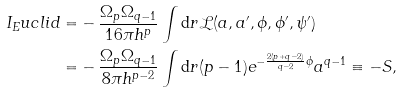Convert formula to latex. <formula><loc_0><loc_0><loc_500><loc_500>I _ { E } u c l i d = & - \frac { \Omega _ { p } \Omega _ { q - 1 } } { 1 6 \pi h ^ { p } } \int \mathrm d r \mathcal { L } ( a , a ^ { \prime } , \phi , \phi ^ { \prime } , \psi ^ { \prime } ) \\ = & - \frac { \Omega _ { p } \Omega _ { q - 1 } } { 8 \pi h ^ { p - 2 } } \int \mathrm d r ( p - 1 ) e ^ { - \frac { 2 ( p + q - 2 ) } { q - 2 } \phi } a ^ { q - 1 } \equiv - S ,</formula> 